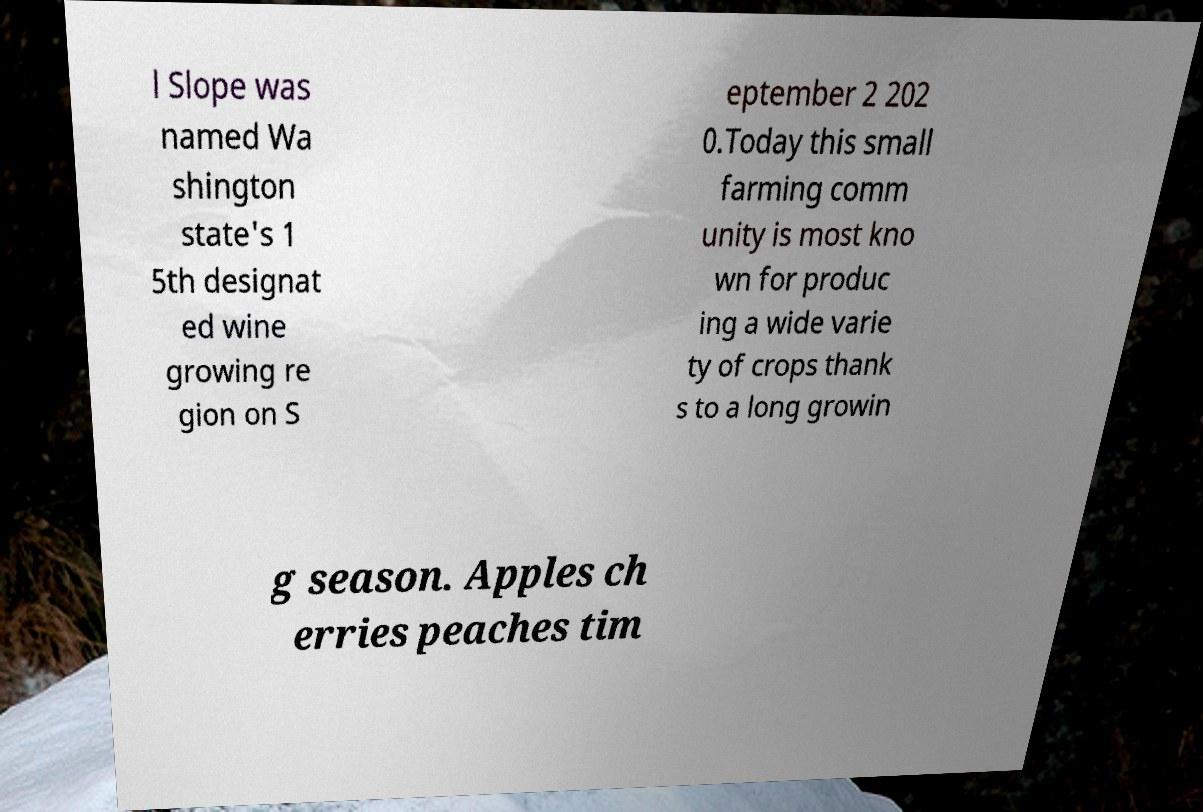For documentation purposes, I need the text within this image transcribed. Could you provide that? l Slope was named Wa shington state's 1 5th designat ed wine growing re gion on S eptember 2 202 0.Today this small farming comm unity is most kno wn for produc ing a wide varie ty of crops thank s to a long growin g season. Apples ch erries peaches tim 